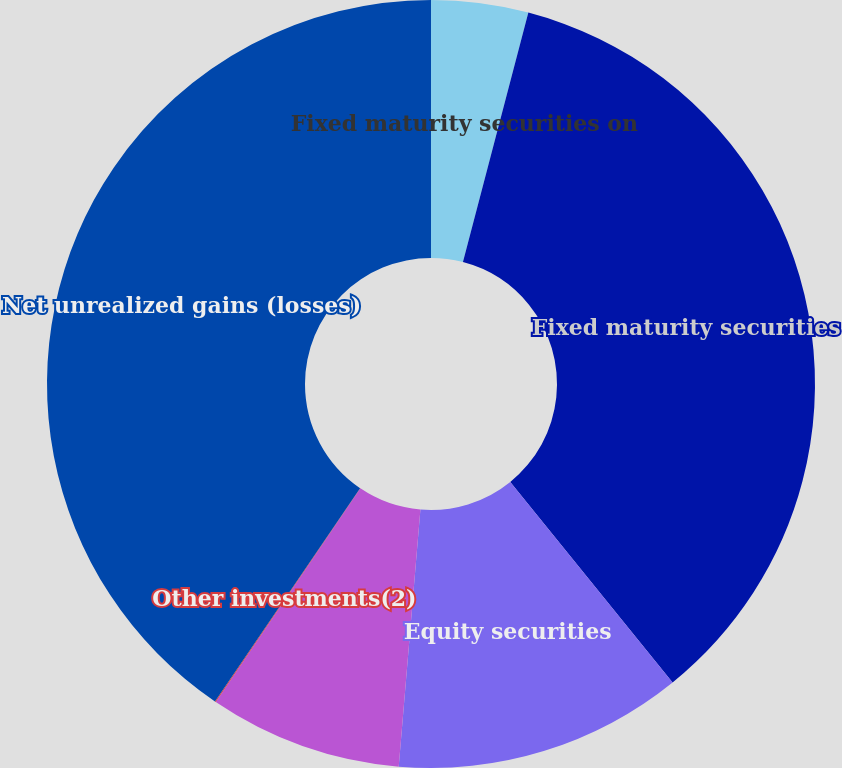Convert chart. <chart><loc_0><loc_0><loc_500><loc_500><pie_chart><fcel>Fixed maturity securities on<fcel>Fixed maturity securities<fcel>Equity securities<fcel>Derivatives designated as cash<fcel>Other investments(2)<fcel>Net unrealized gains (losses)<nl><fcel>4.08%<fcel>35.09%<fcel>12.17%<fcel>8.13%<fcel>0.04%<fcel>40.49%<nl></chart> 